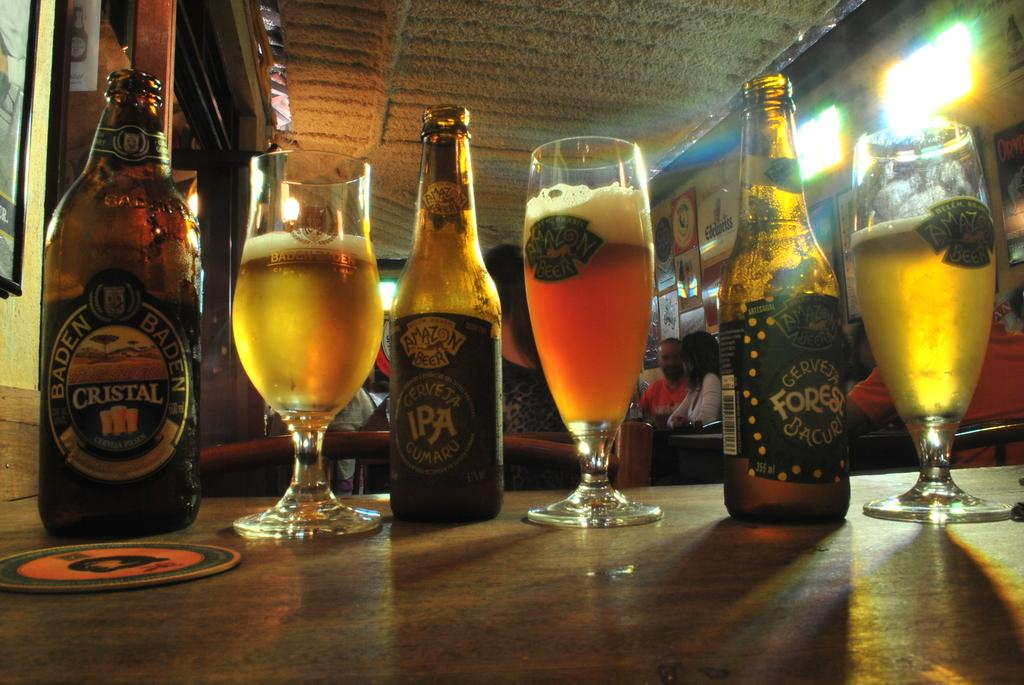<image>
Relay a brief, clear account of the picture shown. bottles and glasses of beer like Cristal and IPA 